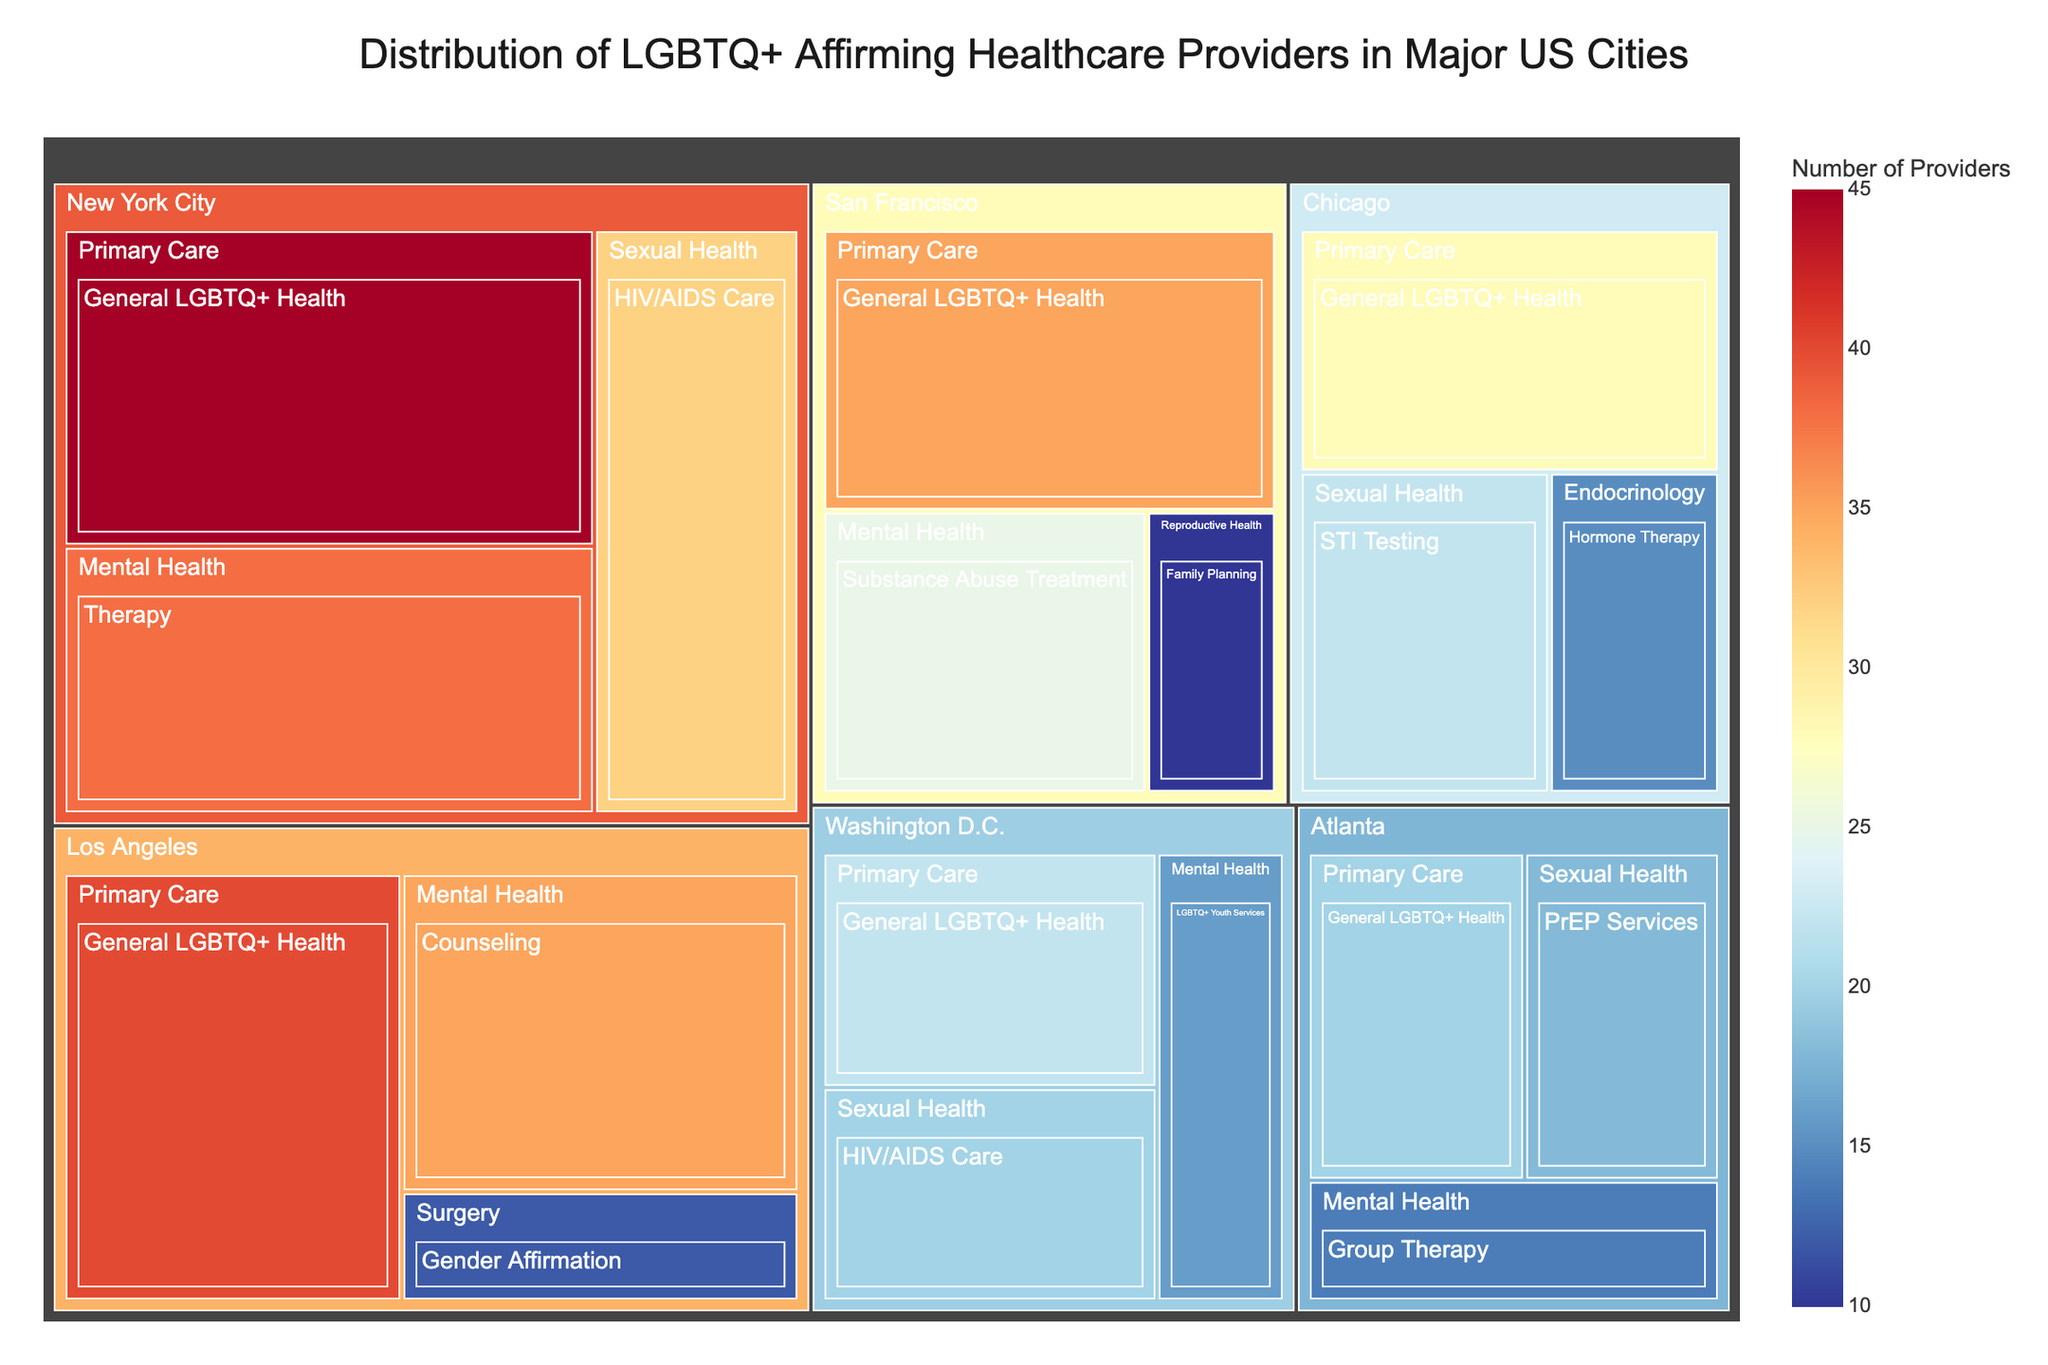what is the title of the treemap? The title is usually located at the top of the treemap and helps summarize the data visualization. In this case, it is "Distribution of LGBTQ+ Affirming Healthcare Providers in Major US Cities."
Answer: Distribution of LGBTQ+ Affirming Healthcare Providers in Major US Cities Which city has the highest number of providers for General LGBTQ+ Health? To find this, locate the "General LGBTQ+ Health" service under the "Primary Care" specialty for each city and compare their provider numbers. New York City has the highest number with 45 providers.
Answer: New York City How many providers are offering Mental Health services in Los Angeles? Under the "Mental Health" specialty within the Los Angeles section, sum the numbers of providers for all related services. There are 35 providers offering counseling in Los Angeles.
Answer: 35 Which specialty has the highest number of providers in Washington D.C.? Navigate to the Washington D.C. section, review the provider numbers for all specialties, and identify the specialty with the highest value. "Primary Care" has the highest with 22 providers.
Answer: Primary Care Compare the number of providers offering HIV/AIDS Care in New York City and Washington D.C. Which city has more providers for this service? Look under the "Sexual Health" specialty for both cities and note the number of providers offering "HIV/AIDS Care." New York City has 32 providers, while Washington D.C. has 20. Therefore, New York City has more providers.
Answer: New York City What is the total number of providers in Chicago across all specialties? Sum all provider numbers for each specialty listed under Chicago. The total is 28 (Primary Care) + 15 (Endocrinology) + 22 (Sexual Health) = 65.
Answer: 65 Identify which city has the fewest providers for Reproductive Health. Check the "Reproductive Health" specialty under all cities and sum the number of providers. San Francisco is the only city with this specialty and it has 10 providers. Therefore, San Francisco has the fewest.
Answer: San Francisco What is the average number of providers for General LGBTQ+ Health across all cities? Sum the providers for General LGBTQ+ Health in all cities (New York City: 45, Chicago: 28, Los Angeles: 40, Atlanta: 20, and San Francisco: 35, Washington D.C.: 22), then divide by the number of cities. The sum is 190, divided by 6 gives an average of approximately 31.7.
Answer: 31.7 Which city offers the widest range of LGBTQ+ healthcare specialties? Identify each city and count the unique specialties listed. The city with the most unique specialties is Los Angeles with specialties in Primary Care, Surgery, and Mental Health, totaling 3.
Answer: Los Angeles Is there a specialty that appears in all the listed cities? Review the specialties for each city and see if any appear in each list. "Primary Care" is the only specialty that appears in every listed city.
Answer: Primary Care 